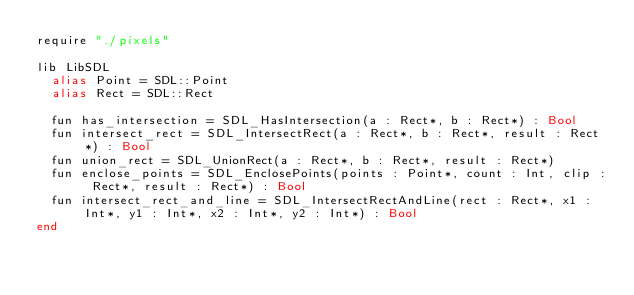Convert code to text. <code><loc_0><loc_0><loc_500><loc_500><_Crystal_>require "./pixels"

lib LibSDL
  alias Point = SDL::Point
  alias Rect = SDL::Rect

  fun has_intersection = SDL_HasIntersection(a : Rect*, b : Rect*) : Bool
  fun intersect_rect = SDL_IntersectRect(a : Rect*, b : Rect*, result : Rect*) : Bool
  fun union_rect = SDL_UnionRect(a : Rect*, b : Rect*, result : Rect*)
  fun enclose_points = SDL_EnclosePoints(points : Point*, count : Int, clip : Rect*, result : Rect*) : Bool
  fun intersect_rect_and_line = SDL_IntersectRectAndLine(rect : Rect*, x1 : Int*, y1 : Int*, x2 : Int*, y2 : Int*) : Bool
end
</code> 